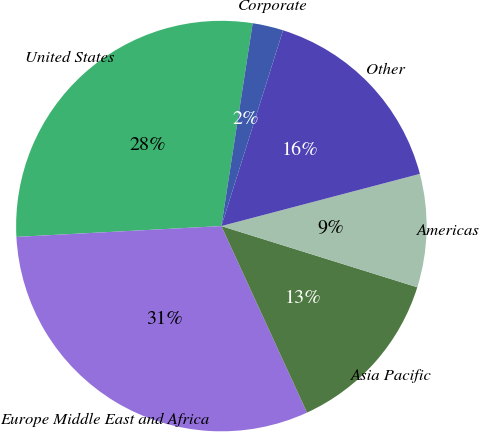<chart> <loc_0><loc_0><loc_500><loc_500><pie_chart><fcel>United States<fcel>Europe Middle East and Africa<fcel>Asia Pacific<fcel>Americas<fcel>Other<fcel>Corporate<nl><fcel>28.28%<fcel>31.01%<fcel>13.33%<fcel>8.91%<fcel>16.05%<fcel>2.42%<nl></chart> 